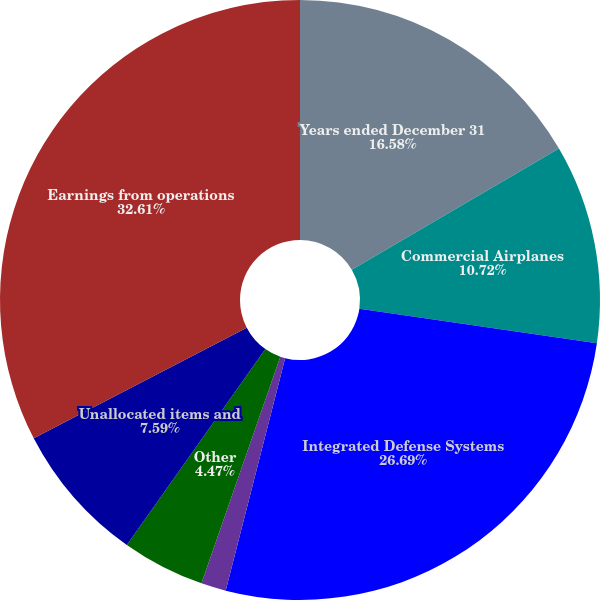Convert chart. <chart><loc_0><loc_0><loc_500><loc_500><pie_chart><fcel>Years ended December 31<fcel>Commercial Airplanes<fcel>Integrated Defense Systems<fcel>Boeing Capital Corporation<fcel>Other<fcel>Unallocated items and<fcel>Earnings from operations<nl><fcel>16.58%<fcel>10.72%<fcel>26.69%<fcel>1.34%<fcel>4.47%<fcel>7.59%<fcel>32.62%<nl></chart> 